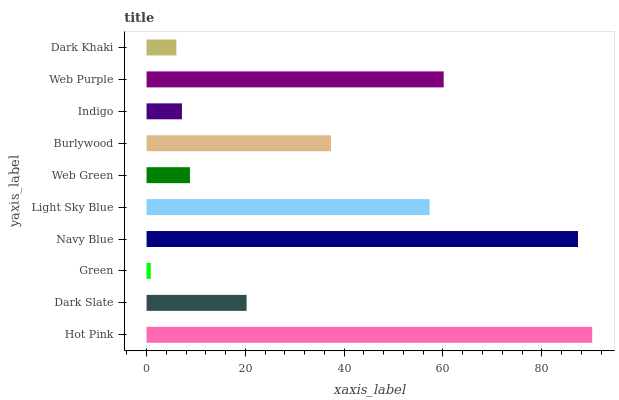Is Green the minimum?
Answer yes or no. Yes. Is Hot Pink the maximum?
Answer yes or no. Yes. Is Dark Slate the minimum?
Answer yes or no. No. Is Dark Slate the maximum?
Answer yes or no. No. Is Hot Pink greater than Dark Slate?
Answer yes or no. Yes. Is Dark Slate less than Hot Pink?
Answer yes or no. Yes. Is Dark Slate greater than Hot Pink?
Answer yes or no. No. Is Hot Pink less than Dark Slate?
Answer yes or no. No. Is Burlywood the high median?
Answer yes or no. Yes. Is Dark Slate the low median?
Answer yes or no. Yes. Is Light Sky Blue the high median?
Answer yes or no. No. Is Web Purple the low median?
Answer yes or no. No. 